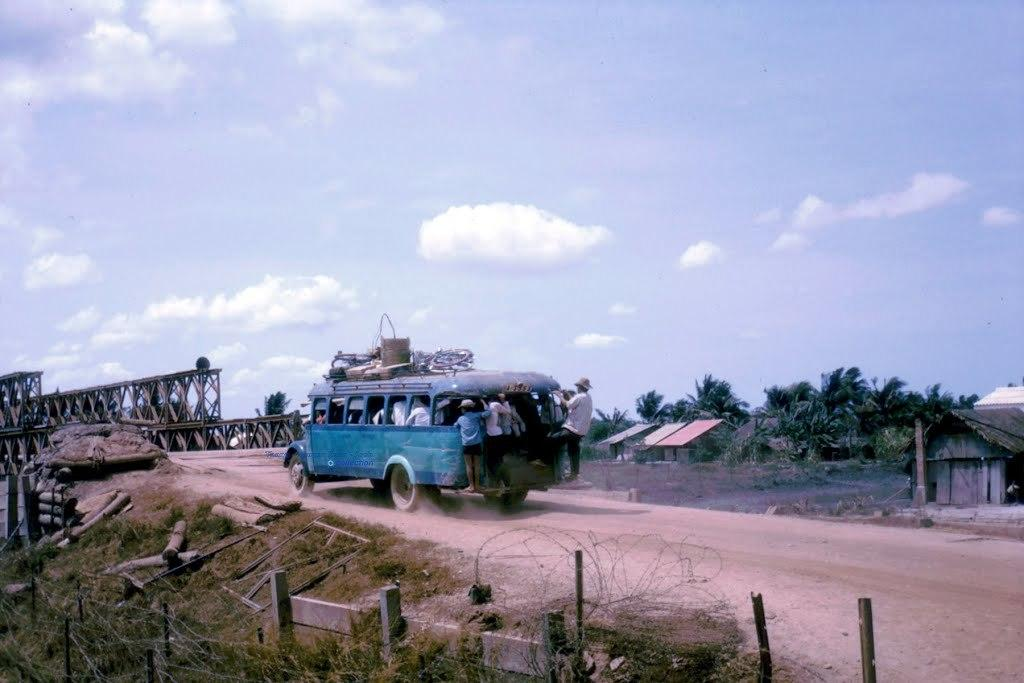What type of natural vegetation can be seen in the image? There are trees and woods in the image. What type of man-made structures are visible in the image? There are buildings and fencing in the image. What type of ground surface is present in the image? There is grass in the image. What type of vertical structures can be seen in the image? There are poles in the image. What type of transportation is present in the image? There is a vehicle in the image. What type of atmospheric conditions are visible in the image? There are clouds in the image, and the sky is visible. Are there any people present in the image? Yes, there are people standing in the image. Where is the faucet located in the image? There is no faucet present in the image. Can you tell me how many airports are visible in the image? There are no airports present in the image. 